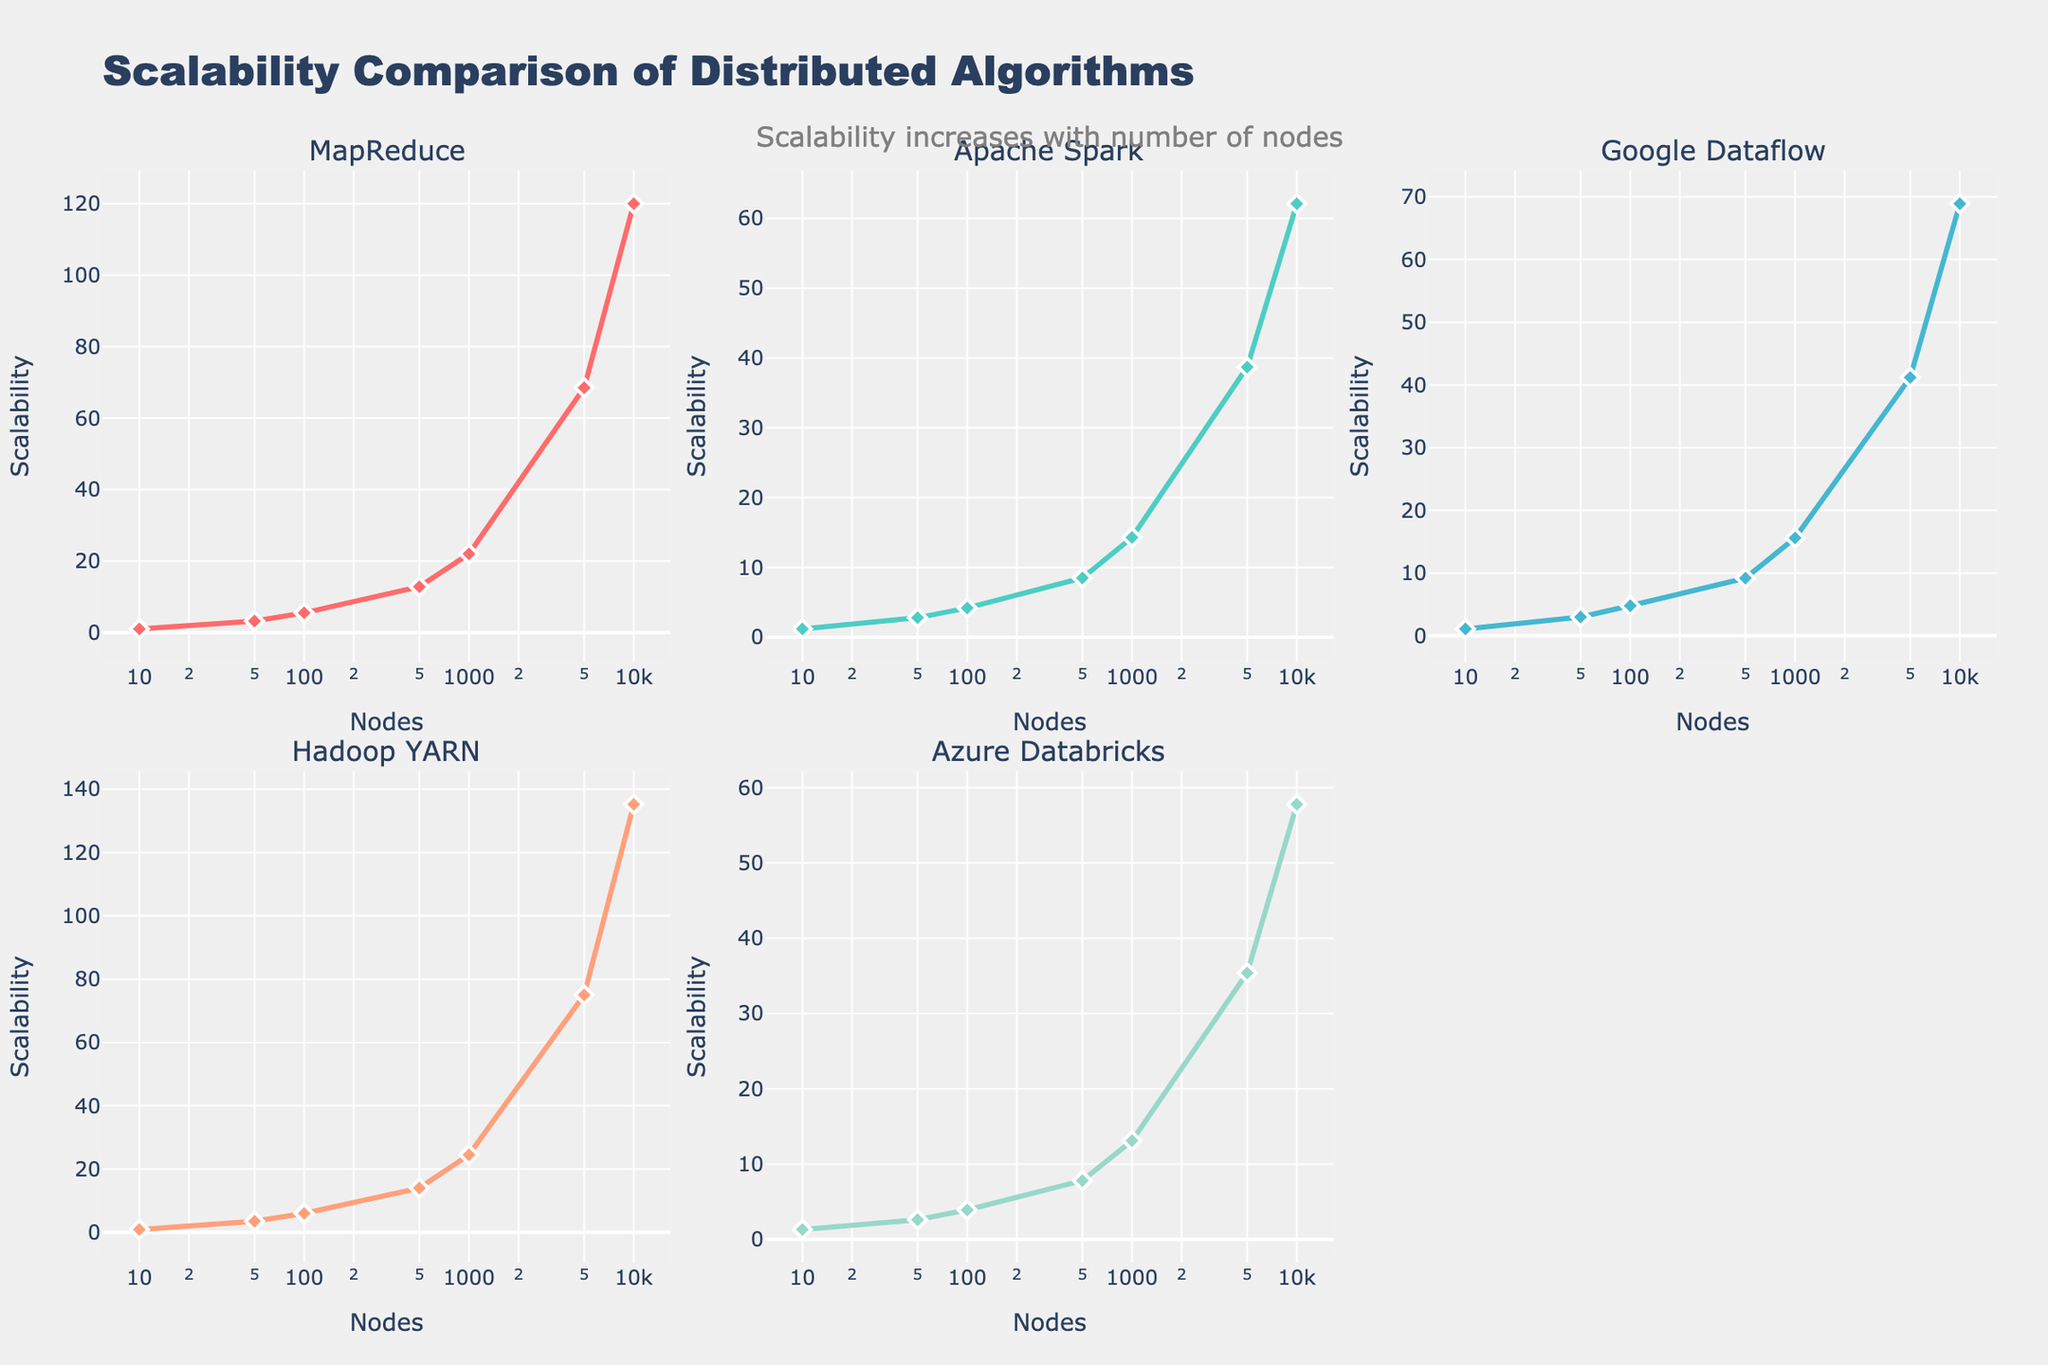What is the title of the figure? The title is prominently displayed at the top of the figure. It reads "Scalability Comparison of Distributed Algorithms".
Answer: Scalability Comparison of Distributed Algorithms What are the algorithms compared in the subplots? The subplot titles list the algorithms being compared. They are MapReduce, Apache Spark, Google Dataflow, Hadoop YARN, and Azure Databricks.
Answer: MapReduce, Apache Spark, Google Dataflow, Hadoop YARN, Azure Databricks Which algorithm has the highest scalability at 10,000 nodes? By looking at the y-values on the plots at 10,000 nodes, the Hadoop YARN subplot exhibits the highest scalability, which is around 135.2.
Answer: Hadoop YARN How does the scalability of Apache Spark compare to MapReduce as the number of nodes increases? Observing the subplots for Apache Spark and MapReduce, we see that MapReduce's scalability increases more steeply than Apache Spark's as nodes increase. For example, at 10,000 nodes, MapReduce is at 120.0 while Apache Spark is at about 62.1.
Answer: MapReduce scales better than Apache Spark as the number of nodes increases What is the difference in scalability between MapReduce and Azure Databricks at 500 nodes? From the subplots, the scalability values at 500 nodes are 12.8 for MapReduce and 7.8 for Azure Databricks. The difference is 12.8 - 7.8 = 5.0.
Answer: 5.0 Which algorithm shows the most linear scalability trend on a log-log scale? The slopes of the lines on the log-log scale subplots are considered. Google Dataflow appears the most linear, maintaining a consistent increase in scalability with the number of nodes.
Answer: Google Dataflow At how many nodes does the scalability of Apache Spark surpass the scalability of Azure Databricks? Checking the plotted values where the scalability of Apache Spark (green line) surpasses Azure Databricks (purple line), it happens between 50 and 100 nodes. At 100 nodes, Apache Spark has a scalability of 4.2, compared to Azure Databricks at 3.9.
Answer: Between 50 and 100 nodes What trend do you observe about the relationship between the number of nodes and the scalability for all algorithms? All subplots show an upward trend, indicating that as the number of nodes increases, scalability also increases for all algorithms.
Answer: Scalability increases with the number of nodes for all algorithms What customization choices in the figure make it clear and easy to interpret? Custom color palette for each algorithm, log-scaled x-axis labeled "Nodes", y-axis labeled "Scalability", and the subplot titles clearly indicating each algorithm. The markers and line styles also aid in differentiating the algorithms.
Answer: Colors, log-scale x-axis, labeled axes, subplot titles, markers, and line styles 